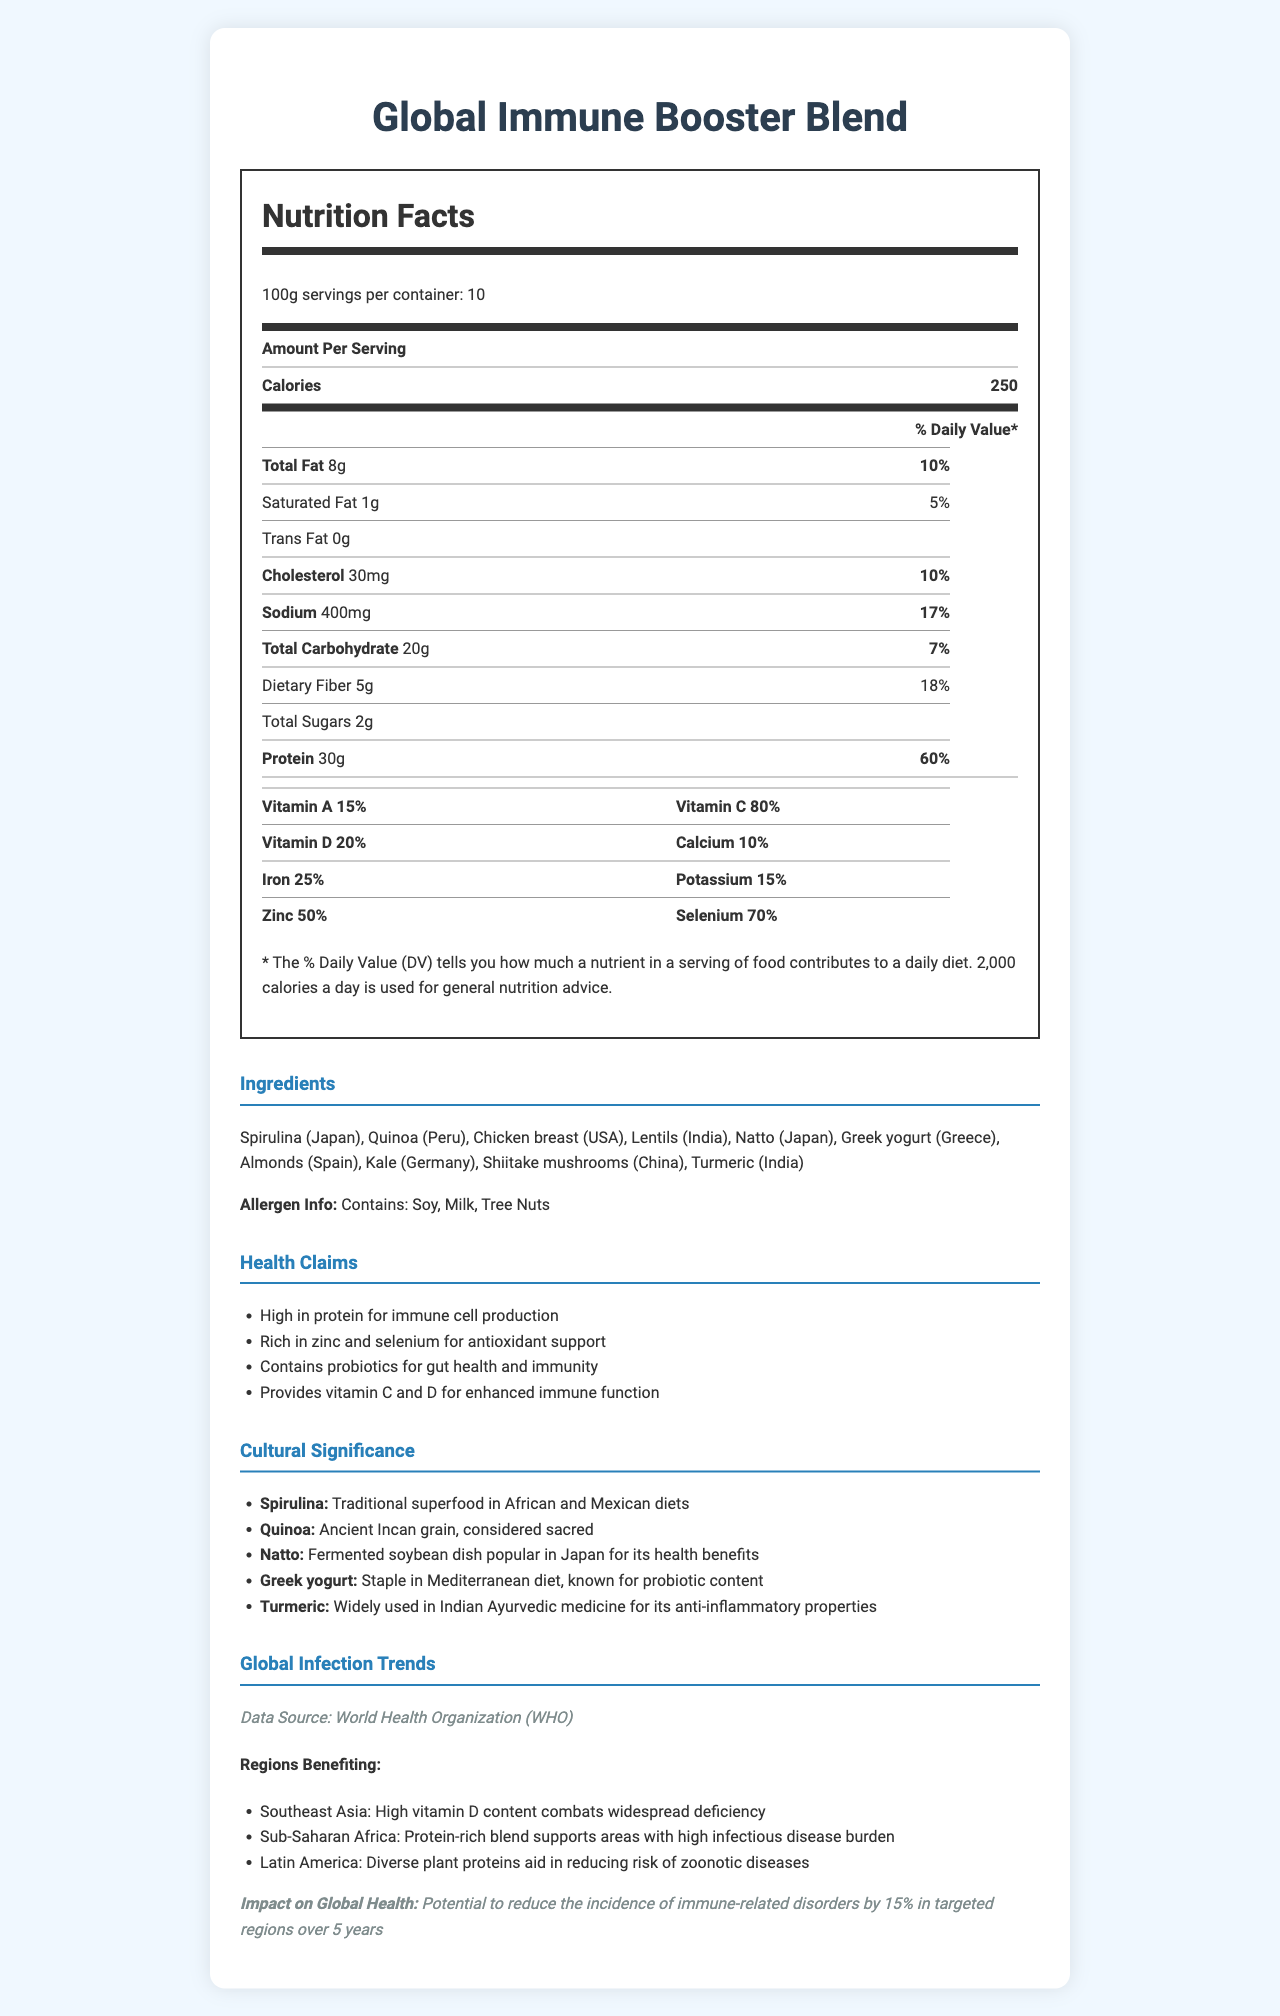what is the serving size of the Global Immune Booster Blend? The serving size is mentioned as 100g in the document.
Answer: 100g how many servings are there per container? The document lists the servings per container as 10.
Answer: 10 how much protein is in one serving? The amount of protein per serving is listed as 30g.
Answer: 30g what percentage of the daily value does vitamin C contribute? The document states that vitamin C provides 80% of the daily value per serving.
Answer: 80% which ingredient is known for its probiotic content and is a staple in the Mediterranean diet? The cultural significance section mentions Greek yogurt as a staple in the Mediterranean diet, known for its probiotic content.
Answer: Greek yogurt how many total carbohydrates are there per serving? The document lists total carbohydrates per serving as 20g.
Answer: 20g which vitamins are mentioned in the nutrition label? A. Vitamin A, Vitamin C, Vitamin D, Vitamin E B. Vitamin A, Vitamin B12, Vitamin D C. Vitamin A, Vitamin C, Vitamin D The nutrition label lists Vitamin A, Vitamin C, and Vitamin D.
Answer: C which of the following regions benefit from the high vitamin D content of the product? 1. Southeast Asia 2. Sub-Saharan Africa 3. Latin America The global infection trends section states that high vitamin D content combats widespread deficiency in Southeast Asia.
Answer: 1 is the Global Immune Booster Blend high in zinc? The document lists zinc as providing 50% of the daily value, indicating that it is high in zinc.
Answer: Yes summarize the main idea of the Global Immune Booster Blend document. The document includes a detailed nutrition facts label, outlines key ingredients and their health benefits, emphasizes the cultural significance of components, and explains the product's potential impact on improving global health by supporting immune function.
Answer: The Global Immune Booster Blend document provides comprehensive nutrition information, listing ingredients and their cultural significance, health claims, and the impact on global infection trends. The product aims to boost the immune system through a rich combination of global ingredients high in protein, vitamins, and minerals. what is the sodium content in one serving? The document specifies the sodium content as 400mg per serving.
Answer: 400mg what ancient grain from Peru is included in the ingredients? The ingredients section lists Quinoa, noting it as an ancient Incan grain.
Answer: Quinoa is there any trans fat in the Global Immune Booster Blend? The document states that there is 0g of trans fat.
Answer: No what is the cultural significance of turmeric in the Global Immune Booster Blend? The cultural significance section mentions that turmeric is widely used in Indian Ayurvedic medicine for its anti-inflammatory properties.
Answer: Widely used in Indian Ayurvedic medicine for its anti-inflammatory properties explain the health benefits of this product? These health benefits are detailed in the health claims section based on the nutritional composition of the product.
Answer: The document outlines several health benefits, including high protein content for immune cell production, rich zinc and selenium for antioxidant support, probiotics for gut health and immunity, and vitamins C and D for enhanced immune function. what data source is mentioned for global infection trends? The global infection trends section states that the data source is the World Health Organization (WHO).
Answer: World Health Organization (WHO) which ingredient from China is included for its health benefits? The ingredients section lists Shiitake mushrooms sourced from China.
Answer: Shiitake mushrooms what percentage of the daily value does selenium contribute per serving? The document lists selenium as contributing 70% of the daily value per serving.
Answer: 70% how might this product potentially reduce immune-related disorders globally? The global infection trends section explains how the nutritional components of the product can globally contribute to better immune function and health.
Answer: By providing a comprehensive blend of high protein, vitamins, minerals, and probiotics, the product aims to strengthen the immune system across various regions, potentially reducing the incidence of immune-related disorders by 15% over 5 years in targeted regions. which health benefit of the product cannot be determined from the document? The document provides general health benefits and potential impact on global health trends but does not offer information on individual immune responses, which requires personalized medical evaluation.
Answer: The exact impact of the product on individual immune responses. 